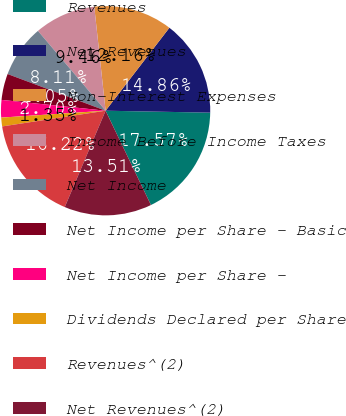Convert chart to OTSL. <chart><loc_0><loc_0><loc_500><loc_500><pie_chart><fcel>Revenues<fcel>Net Revenues<fcel>Non-Interest Expenses<fcel>Income Before Income Taxes<fcel>Net Income<fcel>Net Income per Share - Basic<fcel>Net Income per Share -<fcel>Dividends Declared per Share<fcel>Revenues^(2)<fcel>Net Revenues^(2)<nl><fcel>17.57%<fcel>14.86%<fcel>12.16%<fcel>9.46%<fcel>8.11%<fcel>4.05%<fcel>2.7%<fcel>1.35%<fcel>16.22%<fcel>13.51%<nl></chart> 